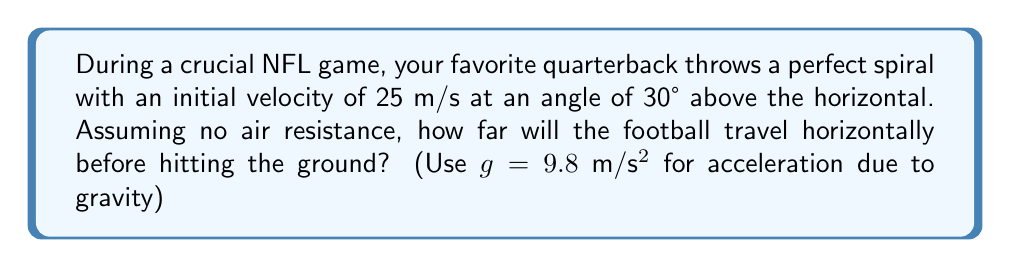Can you answer this question? To solve this problem, we'll use the equations of projectile motion. Let's break it down step-by-step:

1) First, let's identify the known variables:
   - Initial velocity, $v_0 = 25$ m/s
   - Launch angle, $\theta = 30°$
   - Acceleration due to gravity, $g = 9.8$ m/s²

2) We need to find the horizontal distance (range), which is given by the equation:

   $$R = \frac{v_0^2 \sin(2\theta)}{g}$$

3) To use this equation, we need to convert the angle to radians:
   $30° = \frac{\pi}{6}$ radians

4) Now, let's substitute the values into the equation:

   $$R = \frac{(25\text{ m/s})^2 \sin(2 \cdot \frac{\pi}{6})}{9.8\text{ m/s}^2}$$

5) Simplify:
   $$R = \frac{625\text{ m}^2/\text{s}^2 \cdot \sin(\frac{\pi}{3})}{9.8\text{ m/s}^2}$$

6) $\sin(\frac{\pi}{3}) = \frac{\sqrt{3}}{2}$, so:

   $$R = \frac{625\text{ m}^2/\text{s}^2 \cdot \frac{\sqrt{3}}{2}}{9.8\text{ m/s}^2}$$

7) Calculate:
   $$R \approx 55.11\text{ m}$$

Therefore, the football will travel approximately 55.11 meters horizontally before hitting the ground.
Answer: 55.11 m 